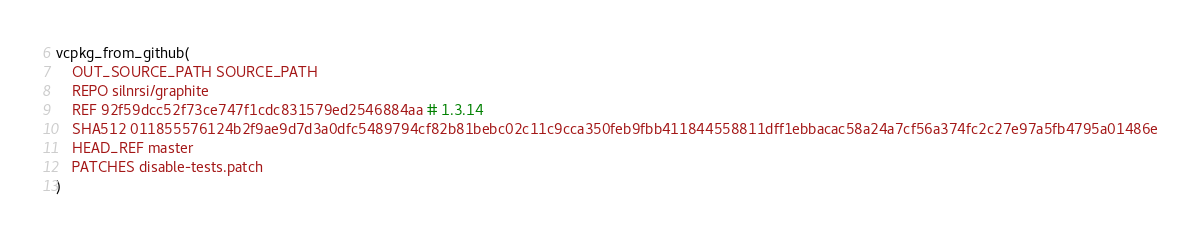<code> <loc_0><loc_0><loc_500><loc_500><_CMake_>vcpkg_from_github(
    OUT_SOURCE_PATH SOURCE_PATH
    REPO silnrsi/graphite
    REF 92f59dcc52f73ce747f1cdc831579ed2546884aa # 1.3.14
    SHA512 011855576124b2f9ae9d7d3a0dfc5489794cf82b81bebc02c11c9cca350feb9fbb411844558811dff1ebbacac58a24a7cf56a374fc2c27e97a5fb4795a01486e
    HEAD_REF master
    PATCHES disable-tests.patch
)
</code> 